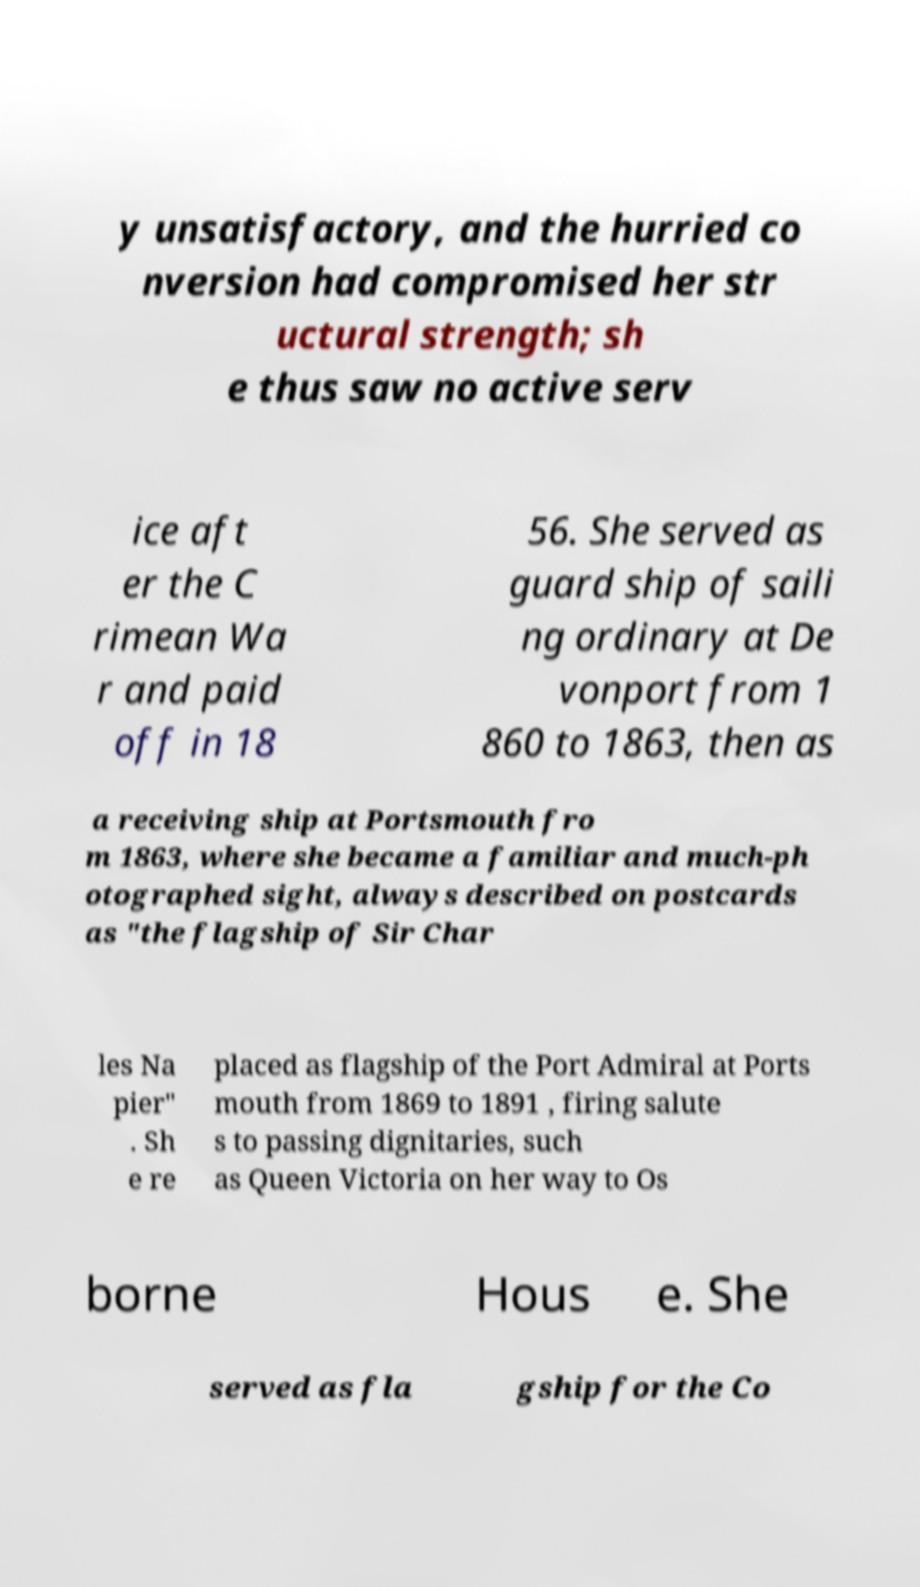Could you assist in decoding the text presented in this image and type it out clearly? y unsatisfactory, and the hurried co nversion had compromised her str uctural strength; sh e thus saw no active serv ice aft er the C rimean Wa r and paid off in 18 56. She served as guard ship of saili ng ordinary at De vonport from 1 860 to 1863, then as a receiving ship at Portsmouth fro m 1863, where she became a familiar and much-ph otographed sight, always described on postcards as "the flagship of Sir Char les Na pier" . Sh e re placed as flagship of the Port Admiral at Ports mouth from 1869 to 1891 , firing salute s to passing dignitaries, such as Queen Victoria on her way to Os borne Hous e. She served as fla gship for the Co 